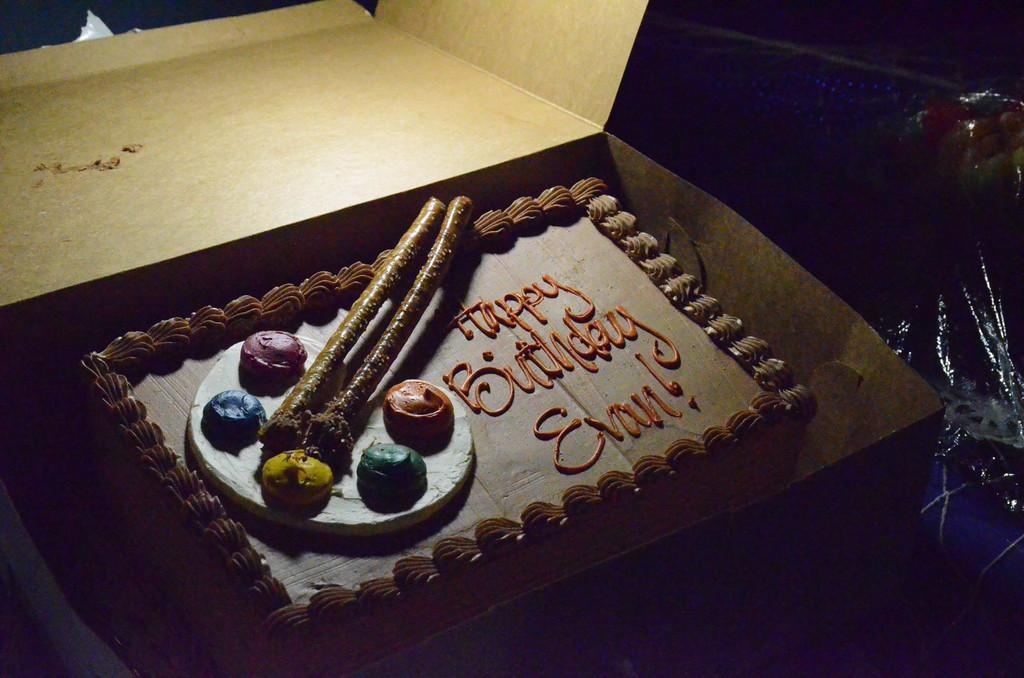What is the main subject of the image? The main subject of the image is a cake. How is the cake being stored or transported in the image? The cake is in a box. What additional detail can be seen on the cake? There is writing on the cake. What type of corn can be seen growing on the cake in the image? There is no corn present on the cake in the image. How does the ice on the cake help it sail across the room? There is no ice on the cake, nor is there any indication that the cake is sailing across the room. 